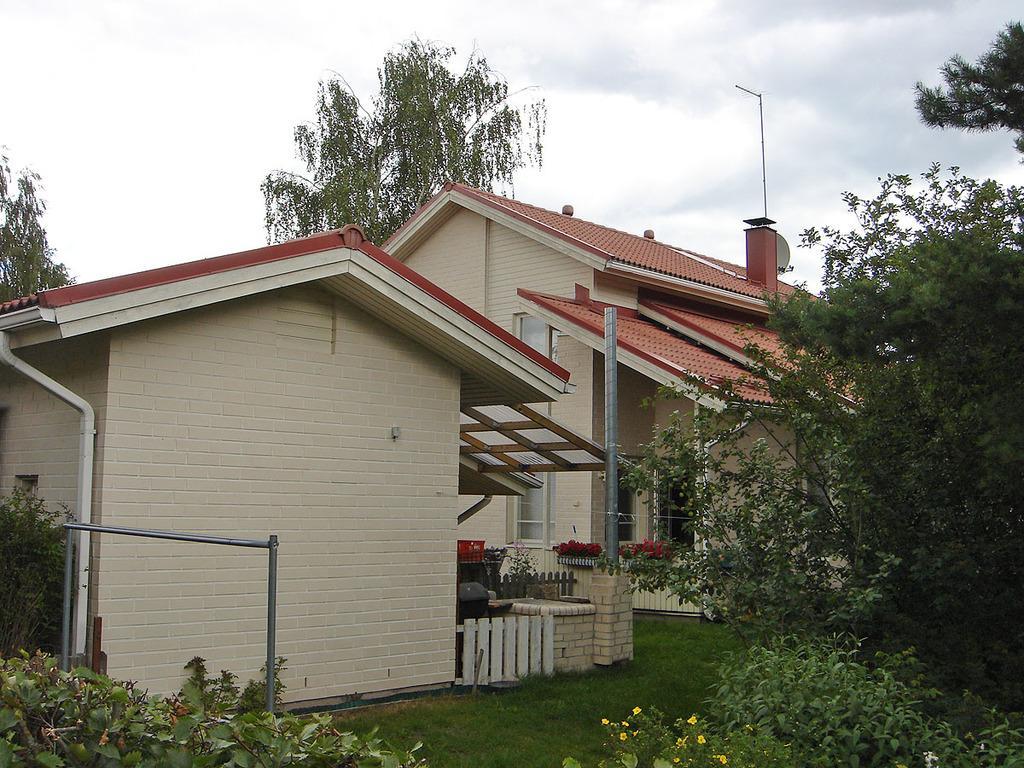Can you describe this image briefly? In this image we can see houses, fence, stainless steel, plants, trees, poles and sky. 